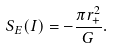Convert formula to latex. <formula><loc_0><loc_0><loc_500><loc_500>S _ { E } ( I ) = - \frac { \pi r _ { + } ^ { 2 } } { G } .</formula> 